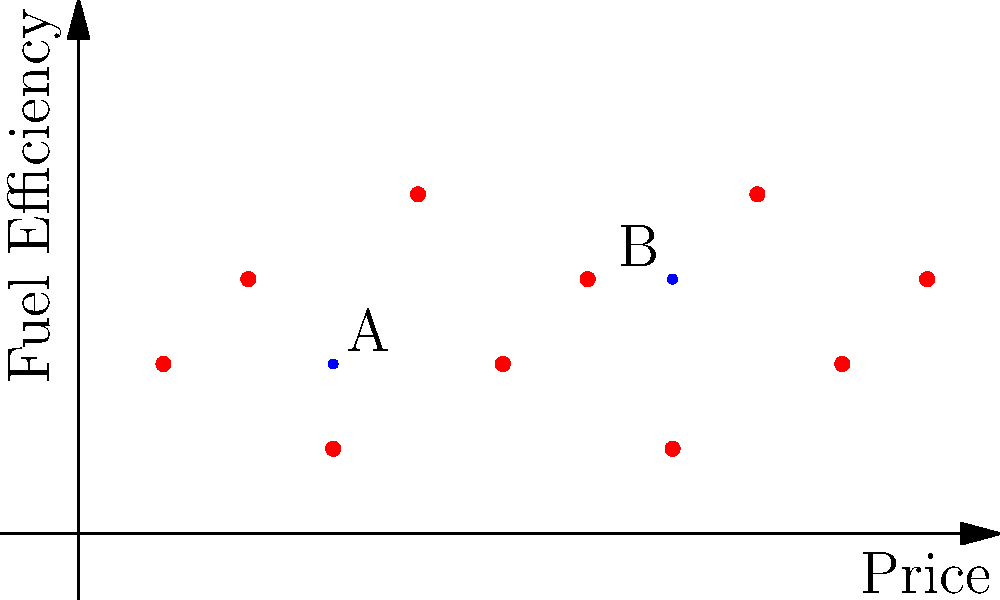As a used car salesman interested in understanding customer preferences, you've plotted customer data for car prices and fuel efficiency using a k-means clustering algorithm. The graph shows two centroids (A and B) and several data points. Based on this visualization, which centroid is likely to represent customers preferring lower-priced, more fuel-efficient cars? To answer this question, we need to analyze the graph and understand what the axes and centroids represent:

1. The x-axis represents the price of cars, with lower values indicating lower prices.
2. The y-axis represents fuel efficiency, with higher values indicating better fuel efficiency.
3. The red dots represent individual customer preferences.
4. The blue dots (A and B) represent the centroids of two clusters.

Now, let's compare the two centroids:

1. Centroid A is located at approximately (3,2) on the graph.
2. Centroid B is located at approximately (7,3) on the graph.

Analyzing their positions:

1. Centroid A is further to the left on the x-axis, indicating lower prices.
2. Centroid A is slightly lower on the y-axis, indicating slightly lower fuel efficiency.
3. Centroid B is further to the right on the x-axis, indicating higher prices.
4. Centroid B is slightly higher on the y-axis, indicating slightly better fuel efficiency.

Although Centroid B shows slightly better fuel efficiency, the difference is minimal compared to the significant difference in price. Customers preferring lower-priced cars would be more likely to cluster around Centroid A.

Therefore, Centroid A is more likely to represent customers preferring lower-priced, more fuel-efficient cars, as the price factor outweighs the small difference in fuel efficiency.
Answer: Centroid A 